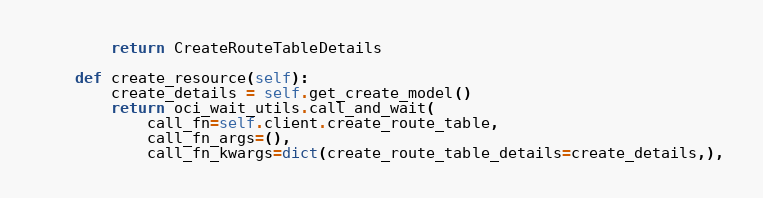<code> <loc_0><loc_0><loc_500><loc_500><_Python_>        return CreateRouteTableDetails

    def create_resource(self):
        create_details = self.get_create_model()
        return oci_wait_utils.call_and_wait(
            call_fn=self.client.create_route_table,
            call_fn_args=(),
            call_fn_kwargs=dict(create_route_table_details=create_details,),</code> 